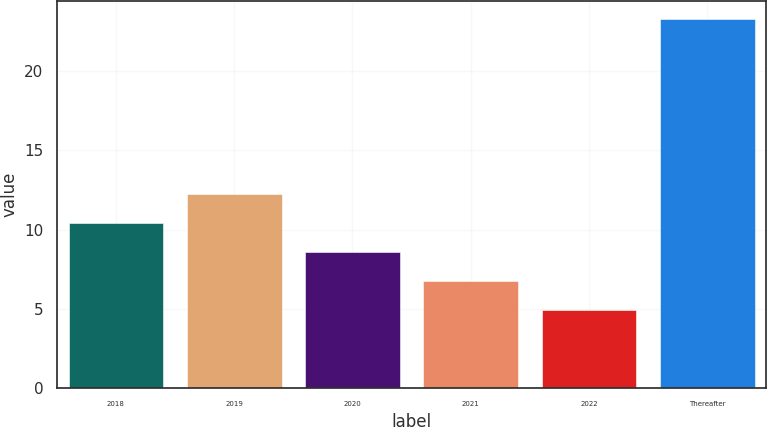Convert chart to OTSL. <chart><loc_0><loc_0><loc_500><loc_500><bar_chart><fcel>2018<fcel>2019<fcel>2020<fcel>2021<fcel>2022<fcel>Thereafter<nl><fcel>10.42<fcel>12.26<fcel>8.58<fcel>6.74<fcel>4.9<fcel>23.3<nl></chart> 